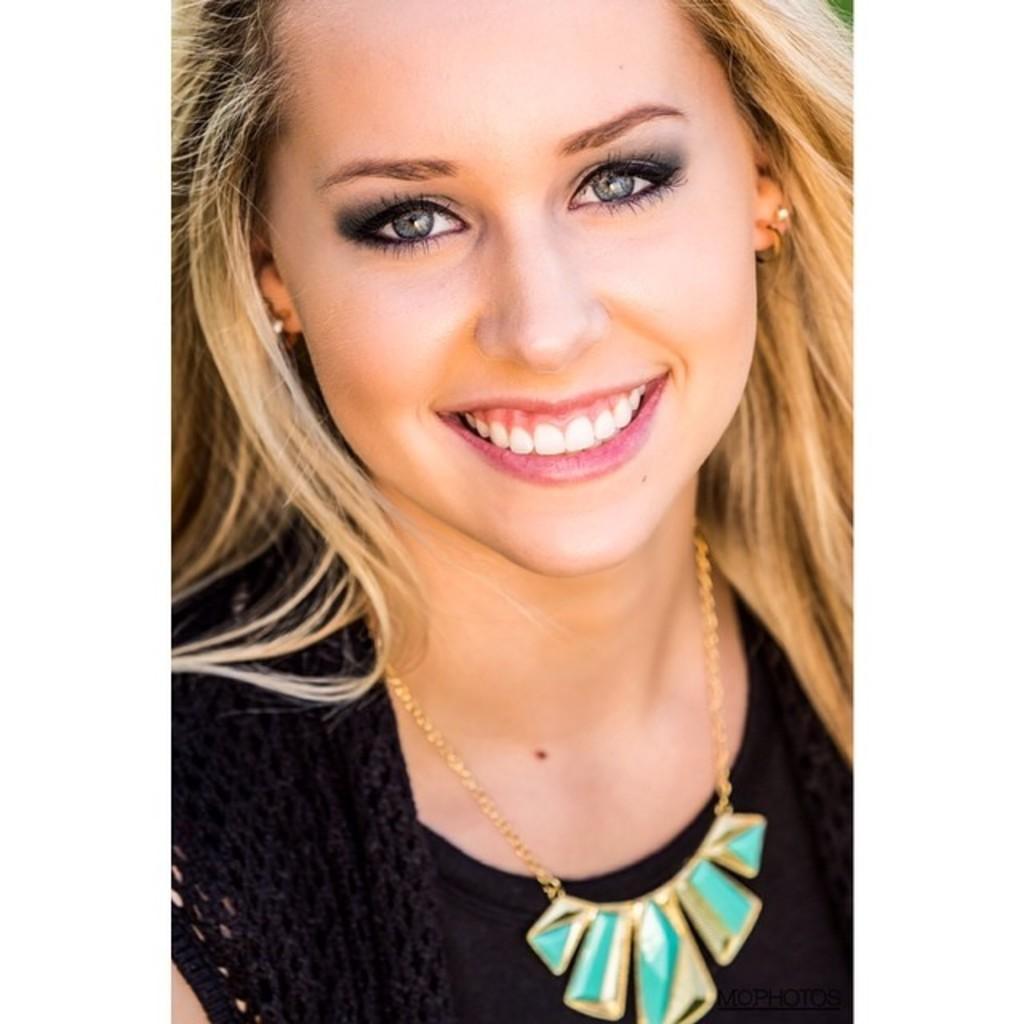In one or two sentences, can you explain what this image depicts? In this image I can see a woman and I can see she is wearing black colour dress. I can also see smile on her face. 